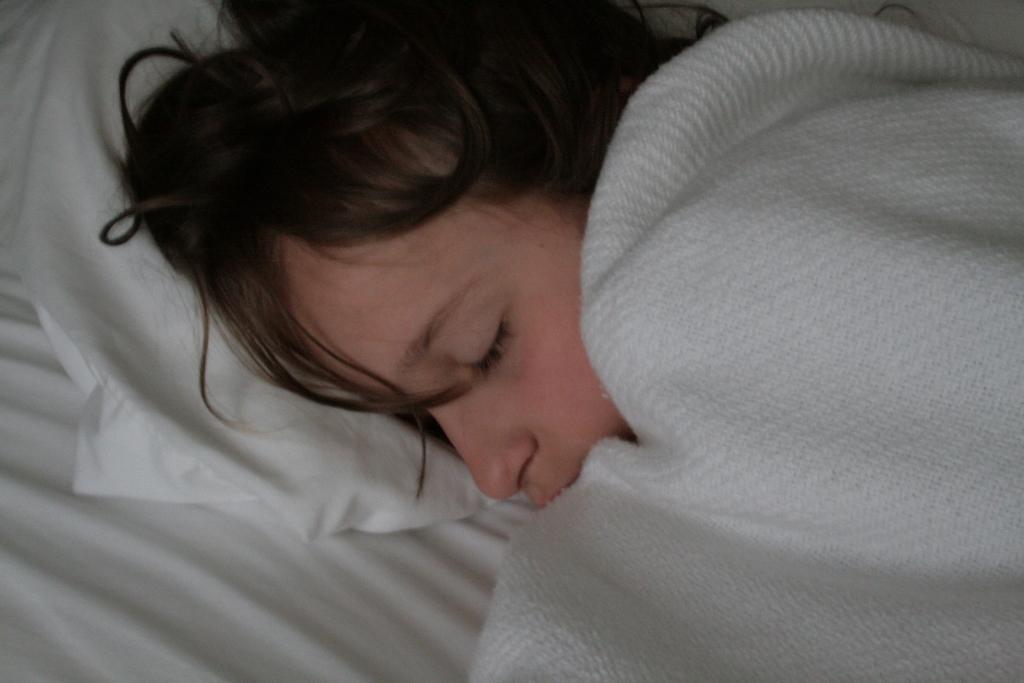Please provide a concise description of this image. In this image we can see a person sleeping on the bed and the person is covering a blanket. 